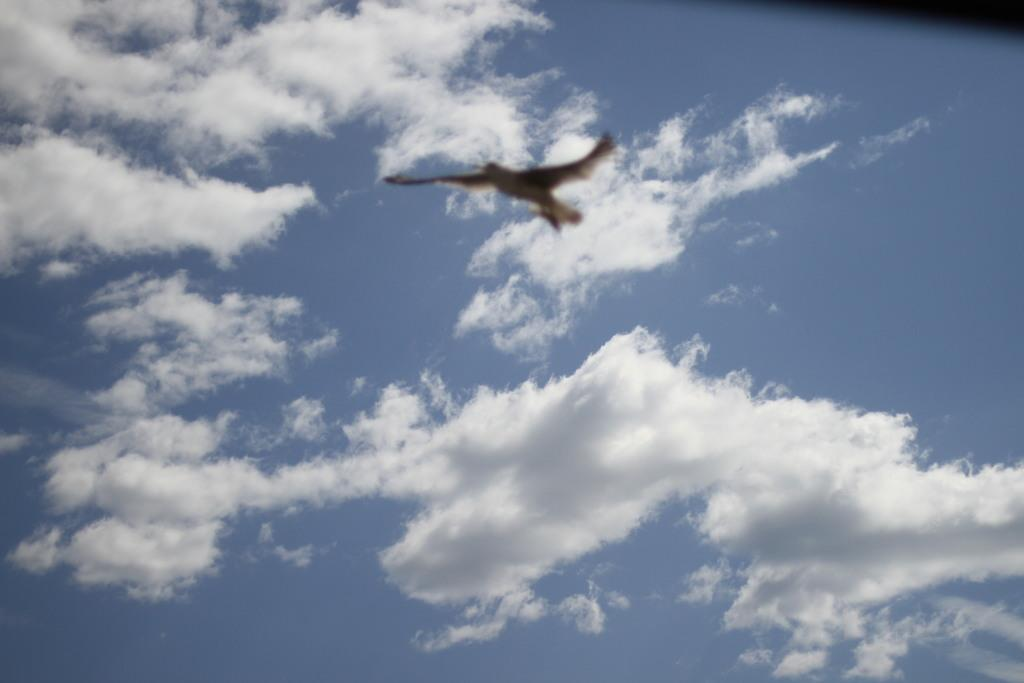Where was the image taken? The image is taken outdoors. What can be seen in the sky in the image? There is a sky with clouds in the image. What is happening in the sky in the image? A bird is flying in the sky in the image. What type of muscle is being flexed by the achiever in the image? There is no achiever or muscle present in the image; it features a sky with clouds and a bird flying in it. 